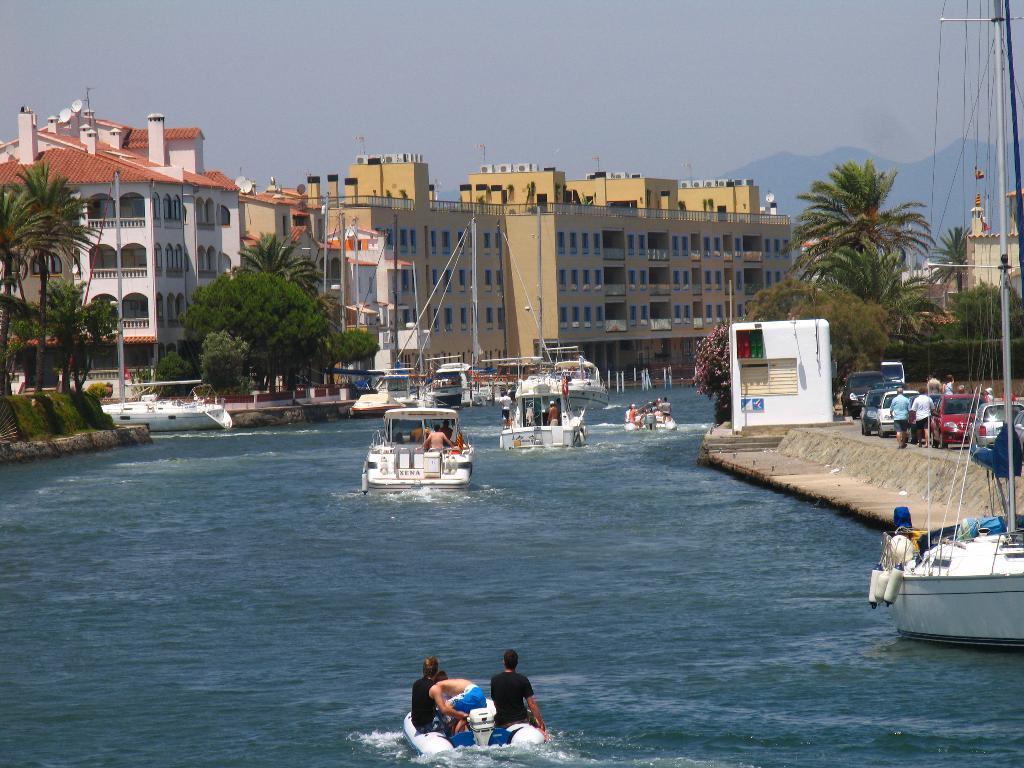Could you give a brief overview of what you see in this image? In this picture we can see many boats on the water. On the right there are two persons were walking on the street. Behind them we can see many cars. In front of them there is a shelter. In the background we can see buildings, trees, mountains. At the bottom we can see the group of persons were riding on the boat. 